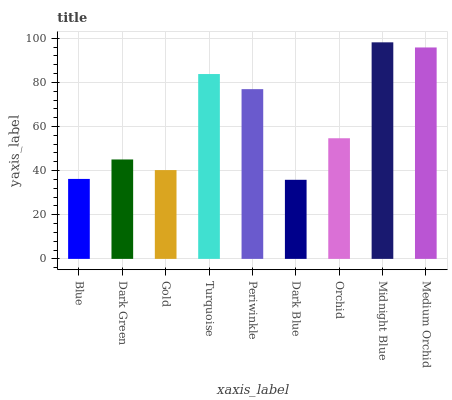Is Dark Green the minimum?
Answer yes or no. No. Is Dark Green the maximum?
Answer yes or no. No. Is Dark Green greater than Blue?
Answer yes or no. Yes. Is Blue less than Dark Green?
Answer yes or no. Yes. Is Blue greater than Dark Green?
Answer yes or no. No. Is Dark Green less than Blue?
Answer yes or no. No. Is Orchid the high median?
Answer yes or no. Yes. Is Orchid the low median?
Answer yes or no. Yes. Is Midnight Blue the high median?
Answer yes or no. No. Is Midnight Blue the low median?
Answer yes or no. No. 